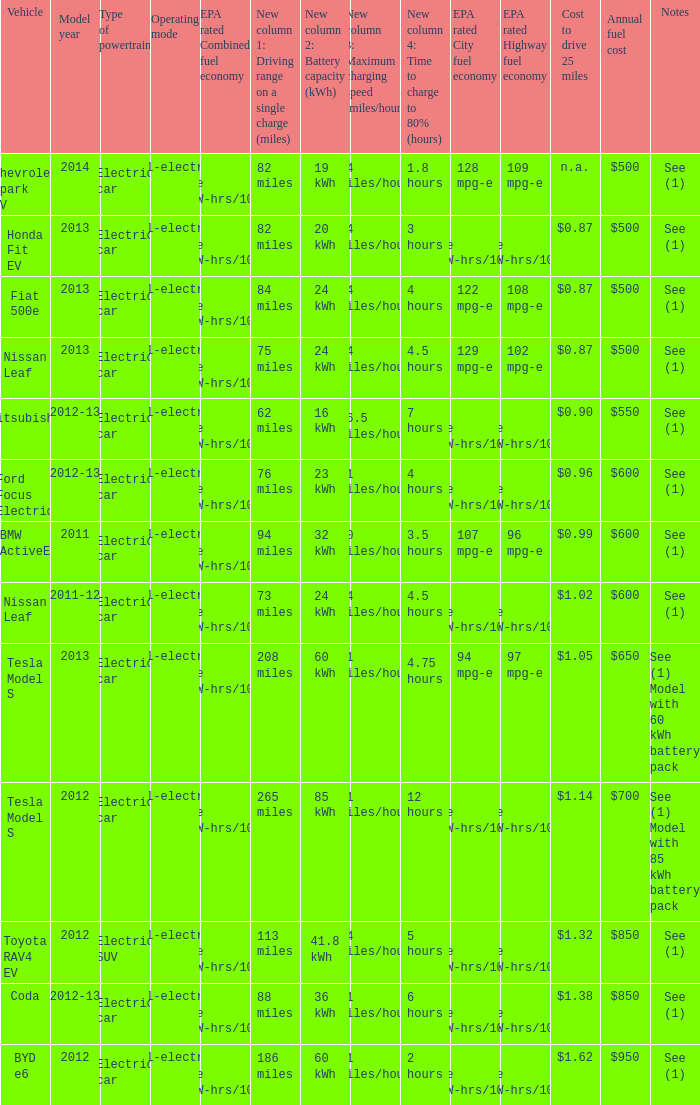What vehicle has an epa highway fuel economy of 109 mpg-e? Chevrolet Spark EV. 